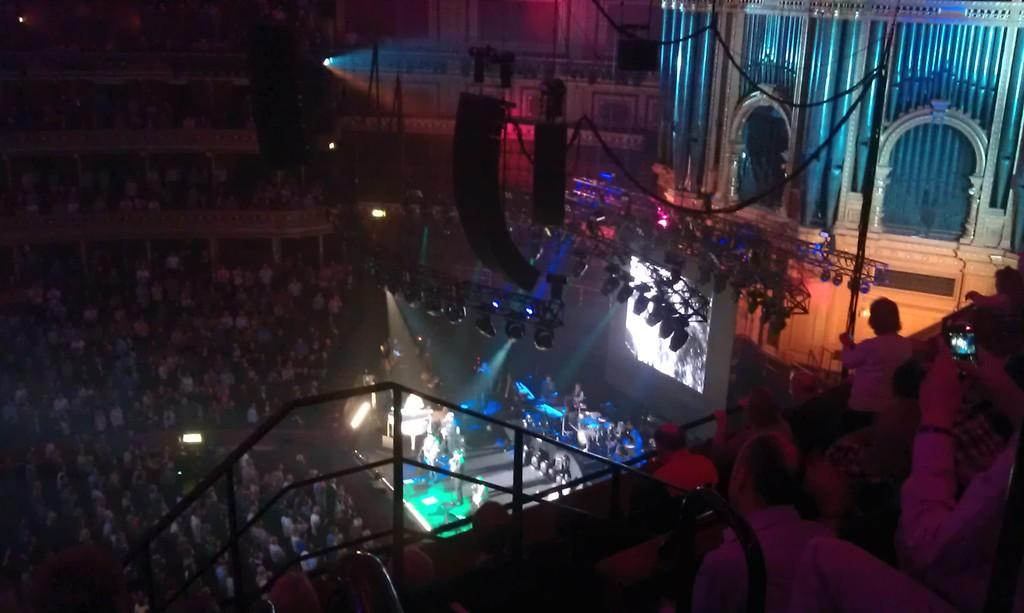How many people are in the image? There is a group of people in the image. Where are some of the people located in the image? Some people are on a stage. What can be seen in the background of the image? There are buildings in the background of the image. What are some people holding in the image? Some people are holding mobiles. How would you describe the lighting in the image? The image appears to be dark. Can you see your dad in the image? There is no information about your dad in the provided facts, so it cannot be determined if he is present in the image. Is the ocean visible in the image? There is no mention of an ocean or any water body in the provided facts, so it cannot be determined if it is visible in the image. 